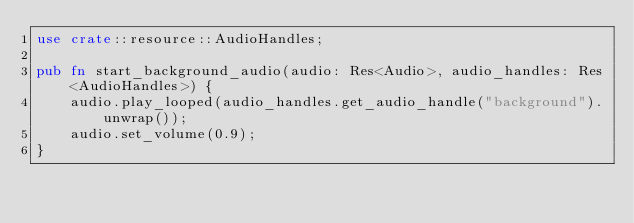<code> <loc_0><loc_0><loc_500><loc_500><_Rust_>use crate::resource::AudioHandles;

pub fn start_background_audio(audio: Res<Audio>, audio_handles: Res<AudioHandles>) {
    audio.play_looped(audio_handles.get_audio_handle("background").unwrap());
    audio.set_volume(0.9);
}
</code> 